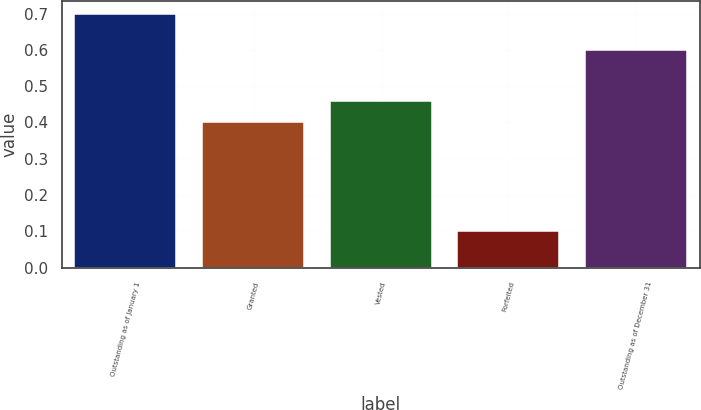Convert chart. <chart><loc_0><loc_0><loc_500><loc_500><bar_chart><fcel>Outstanding as of January 1<fcel>Granted<fcel>Vested<fcel>Forfeited<fcel>Outstanding as of December 31<nl><fcel>0.7<fcel>0.4<fcel>0.46<fcel>0.1<fcel>0.6<nl></chart> 